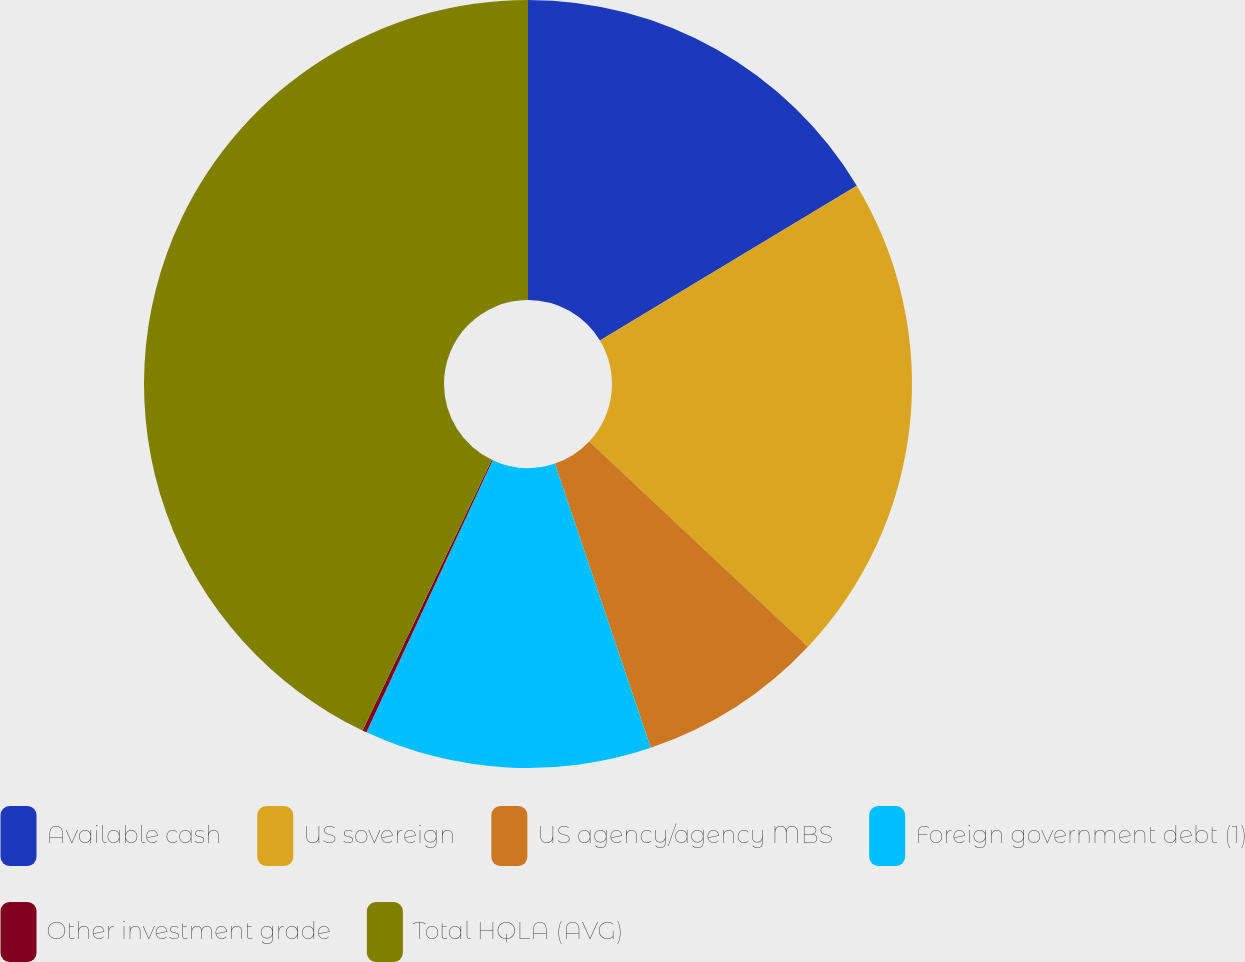Convert chart to OTSL. <chart><loc_0><loc_0><loc_500><loc_500><pie_chart><fcel>Available cash<fcel>US sovereign<fcel>US agency/agency MBS<fcel>Foreign government debt (1)<fcel>Other investment grade<fcel>Total HQLA (AVG)<nl><fcel>16.36%<fcel>20.64%<fcel>7.82%<fcel>12.09%<fcel>0.18%<fcel>42.91%<nl></chart> 